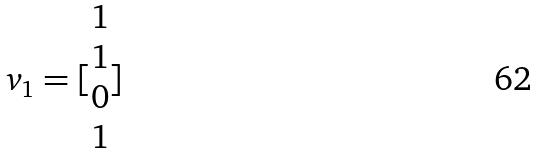Convert formula to latex. <formula><loc_0><loc_0><loc_500><loc_500>v _ { 1 } = [ \begin{matrix} 1 \\ 1 \\ 0 \\ 1 \end{matrix} ]</formula> 